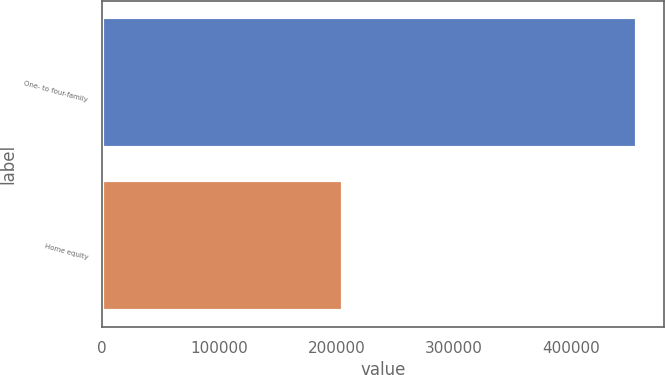<chart> <loc_0><loc_0><loc_500><loc_500><bar_chart><fcel>One- to four-family<fcel>Home equity<nl><fcel>456109<fcel>205879<nl></chart> 